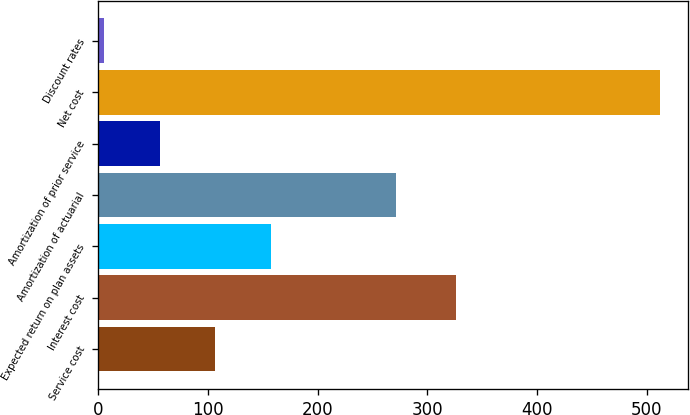Convert chart to OTSL. <chart><loc_0><loc_0><loc_500><loc_500><bar_chart><fcel>Service cost<fcel>Interest cost<fcel>Expected return on plan assets<fcel>Amortization of actuarial<fcel>Amortization of prior service<fcel>Net cost<fcel>Discount rates<nl><fcel>106.56<fcel>326<fcel>157.24<fcel>271<fcel>55.88<fcel>512<fcel>5.2<nl></chart> 